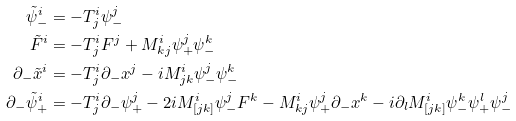<formula> <loc_0><loc_0><loc_500><loc_500>\tilde { \psi } _ { - } ^ { i } & = - T _ { j } ^ { i } \psi _ { - } ^ { j } \\ \tilde { F } ^ { i } & = - T _ { j } ^ { i } F ^ { j } + M _ { k j } ^ { i } \psi _ { + } ^ { j } \psi _ { - } ^ { k } \\ \partial _ { - } \tilde { x } ^ { i } & = - T _ { j } ^ { i } \partial _ { - } x ^ { j } - i M _ { j k } ^ { i } \psi _ { - } ^ { j } \psi _ { - } ^ { k } \\ \partial _ { - } \tilde { \psi } _ { + } ^ { i } & = - T _ { j } ^ { i } \partial _ { - } \psi _ { + } ^ { j } - 2 i M _ { [ j k ] } ^ { i } \psi _ { - } ^ { j } F ^ { k } - M _ { k j } ^ { i } \psi _ { + } ^ { j } \partial _ { - } x ^ { k } - i \partial _ { l } M _ { [ j k ] } ^ { i } \psi _ { - } ^ { k } \psi _ { + } ^ { l } \psi _ { - } ^ { j }</formula> 